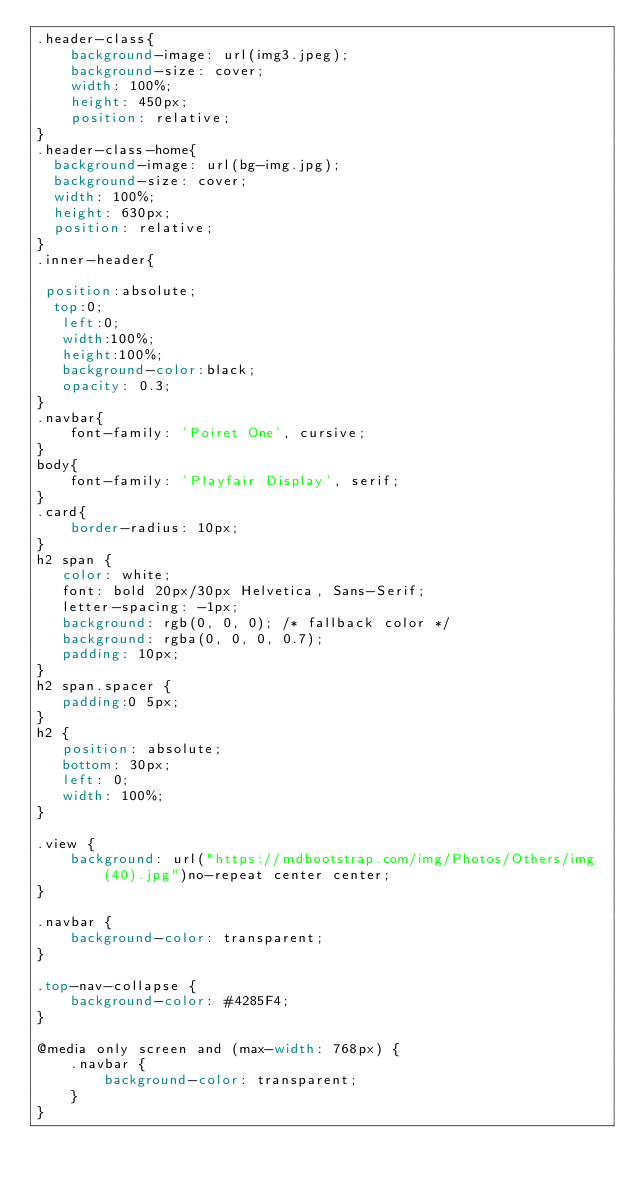Convert code to text. <code><loc_0><loc_0><loc_500><loc_500><_CSS_>.header-class{
	background-image: url(img3.jpeg);
	background-size: cover;
	width: 100%;
	height: 450px;
 	position: relative;
}
.header-class-home{
  background-image: url(bg-img.jpg);
  background-size: cover;
  width: 100%;
  height: 630px;
  position: relative;
}
.inner-header{

 position:absolute;
  top:0;
   left:0;
   width:100%;
   height:100%;
   background-color:black;
   opacity: 0.3; 
}
.navbar{
	font-family: 'Poiret One', cursive;
}
body{
	font-family: 'Playfair Display', serif;
}
.card{
	border-radius: 10px;
}
h2 span { 
   color: white; 
   font: bold 20px/30px Helvetica, Sans-Serif; 
   letter-spacing: -1px;  
   background: rgb(0, 0, 0); /* fallback color */
   background: rgba(0, 0, 0, 0.7);
   padding: 10px; 
}
h2 span.spacer {
   padding:0 5px;
}
h2 { 
   position: absolute; 
   bottom: 30px; 
   left: 0; 
   width: 100%; 
}
                
.view {
    background: url("https://mdbootstrap.com/img/Photos/Others/img (40).jpg")no-repeat center center;
}
    
.navbar {
    background-color: transparent;
}

.top-nav-collapse {
    background-color: #4285F4;
}

@media only screen and (max-width: 768px) {
    .navbar {
        background-color: transparent;
    }
}</code> 